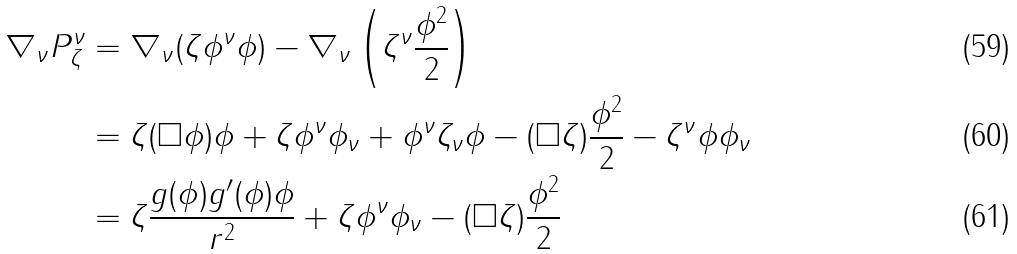<formula> <loc_0><loc_0><loc_500><loc_500>\nabla _ { \nu } P ^ { \nu } _ { \zeta } & = \nabla _ { \nu } ( \zeta \phi ^ { \nu } \phi ) - \nabla _ { \nu } \left ( \zeta ^ { \nu } \frac { \phi ^ { 2 } } { 2 } \right ) \\ & = \zeta ( \square \phi ) \phi + \zeta \phi ^ { \nu } \phi _ { \nu } + \phi ^ { \nu } \zeta _ { \nu } \phi - ( \square \zeta ) \frac { \phi ^ { 2 } } { 2 } - \zeta ^ { \nu } \phi \phi _ { \nu } \\ & = \zeta \frac { g ( \phi ) g ^ { \prime } ( \phi ) \phi } { r ^ { 2 } } + \zeta \phi ^ { \nu } \phi _ { \nu } - ( \square \zeta ) \frac { \phi ^ { 2 } } { 2 }</formula> 